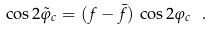<formula> <loc_0><loc_0><loc_500><loc_500>\cos 2 \tilde { \varphi } _ { c } = ( f - \bar { f } ) \, \cos 2 \varphi _ { c } \ .</formula> 